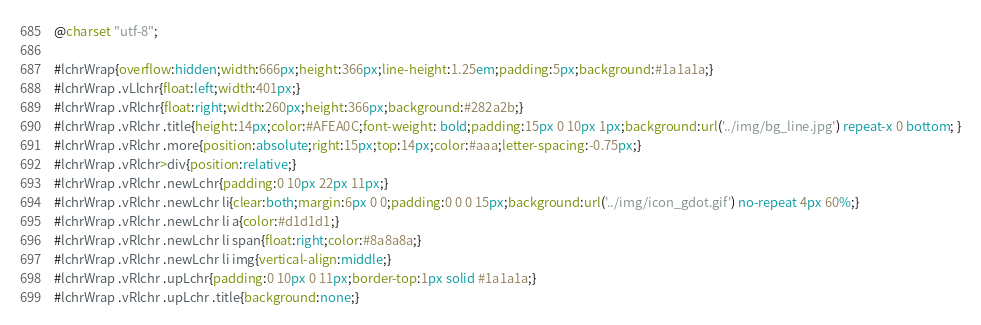<code> <loc_0><loc_0><loc_500><loc_500><_CSS_>@charset "utf-8";

#lchrWrap{overflow:hidden;width:666px;height:366px;line-height:1.25em;padding:5px;background:#1a1a1a;}
#lchrWrap .vLlchr{float:left;width:401px;}
#lchrWrap .vRlchr{float:right;width:260px;height:366px;background:#282a2b;}
#lchrWrap .vRlchr .title{height:14px;color:#AFEA0C;font-weight: bold;padding:15px 0 10px 1px;background:url('../img/bg_line.jpg') repeat-x 0 bottom; }
#lchrWrap .vRlchr .more{position:absolute;right:15px;top:14px;color:#aaa;letter-spacing:-0.75px;}
#lchrWrap .vRlchr>div{position:relative;}
#lchrWrap .vRlchr .newLchr{padding:0 10px 22px 11px;}
#lchrWrap .vRlchr .newLchr li{clear:both;margin:6px 0 0;padding:0 0 0 15px;background:url('../img/icon_gdot.gif') no-repeat 4px 60%;}
#lchrWrap .vRlchr .newLchr li a{color:#d1d1d1;}
#lchrWrap .vRlchr .newLchr li span{float:right;color:#8a8a8a;}
#lchrWrap .vRlchr .newLchr li img{vertical-align:middle;}
#lchrWrap .vRlchr .upLchr{padding:0 10px 0 11px;border-top:1px solid #1a1a1a;}
#lchrWrap .vRlchr .upLchr .title{background:none;}
</code> 